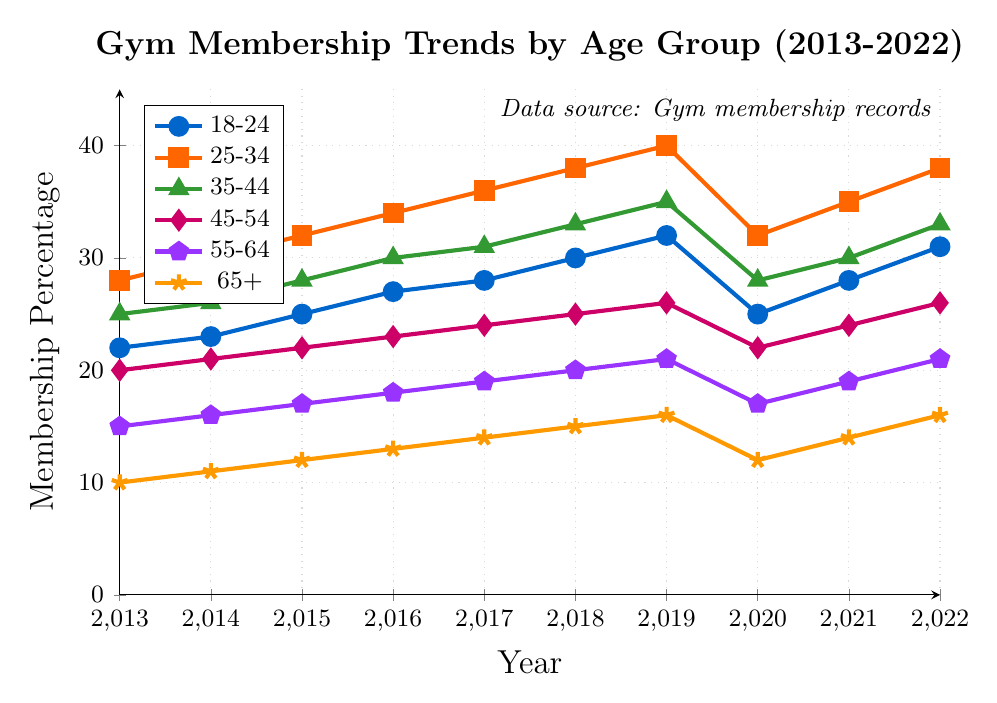What age group saw the most significant drop in gym membership percentage in 2020? To find the age group with the most significant drop, compare the membership percentages from 2019 to 2020 across all age groups. The decrease is calculated as (2019 value - 2020 value) for each group. The 25-34 age group had the highest drop from 40 to 32, a difference of 8.
Answer: 25-34 Which age group had the highest gym membership percentage in 2022? Review the data points for each age group for 2022 and identify the group with the highest membership percentage. The 25-34 age group had the highest percentage of 38.
Answer: 25-34 In which year did the 18-24 age group see its highest gym membership percentage? Look at the values for the 18-24 age group from 2013 to 2022. The highest percentage was in 2022 with a value of 31.
Answer: 2022 How did the gym membership percentage of the 65+ age group change from 2016 to 2022? Calculate the difference between the values for the 65+ age group in 2016 and 2022. The percentage in 2016 was 13 and in 2022 it was 16, an increase of 3.
Answer: Increased by 3 What is the average gym membership percentage for the 35-44 age group from 2013 to 2022? Sum the percentages for the 35-44 age group from all provided years and divide by the number of years. Sum = 25+26+28+30+31+33+35+28+30+33 = 294. The average is 294 / 10 = 29.4.
Answer: 29.4 Compare the gym membership data for the 55-64 and 65+ age groups in 2013. Which group had a higher membership percentage? Look at the membership percentages for both age groups in 2013. The 55-64 age group had 15, while the 65+ age group had 10. The 55-64 group had a higher membership percentage.
Answer: 55-64 Which year saw the highest overall gym membership percentage across all age groups? Sum the membership percentages for all age groups for each year and compare to find the maximum. 2019 had the highest total: 32+40+35+26+21+16 = 170.
Answer: 2019 From 2013 to 2022, which age group showed the most consistent increase in gym membership percentage? Examine the trend lines and values for each age group from 2013 to 2022. The 25-34 age group showed the most consistent increase, rising from 28 in 2013 to 38 in 2022 with a temporary dip in 2020.
Answer: 25-34 In which year did all age groups collectively experience a noticeable decline in gym membership? Identify the year where most of the age groups have a lower membership percentage compared to the previous year. This was apparent in 2020 where all age groups had lower percentages compared to 2019.
Answer: 2020 